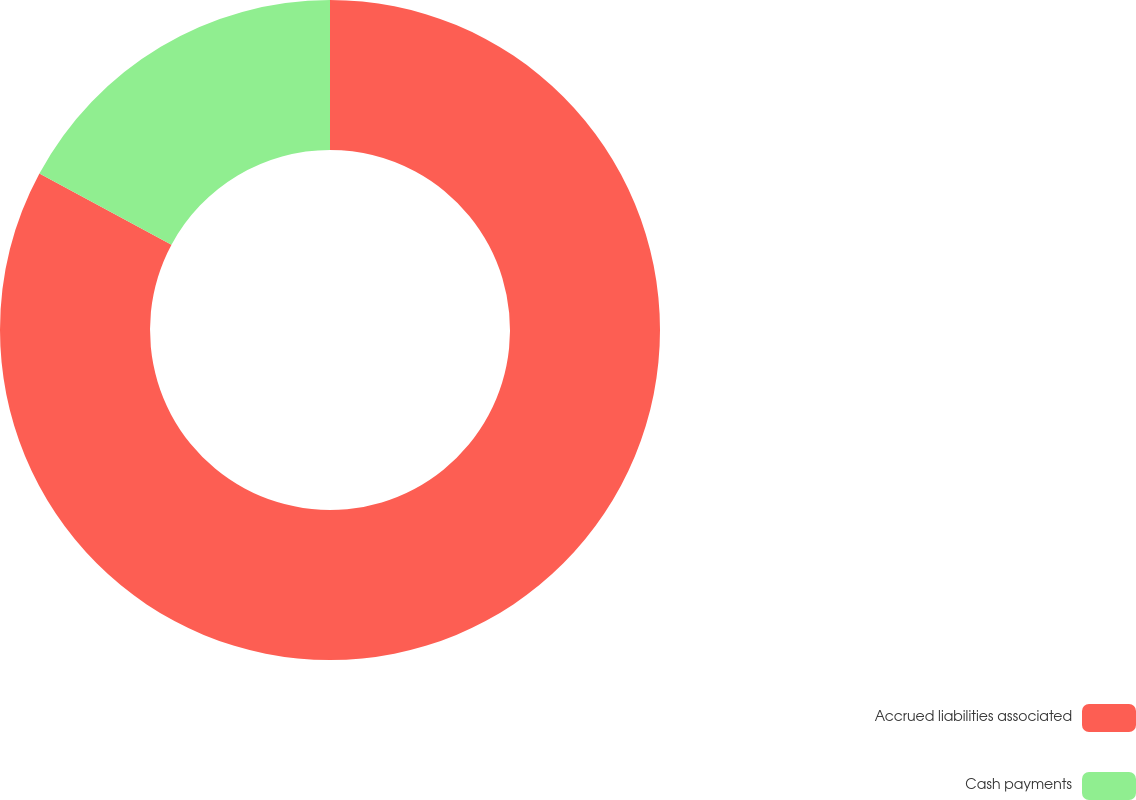Convert chart to OTSL. <chart><loc_0><loc_0><loc_500><loc_500><pie_chart><fcel>Accrued liabilities associated<fcel>Cash payments<nl><fcel>82.86%<fcel>17.14%<nl></chart> 